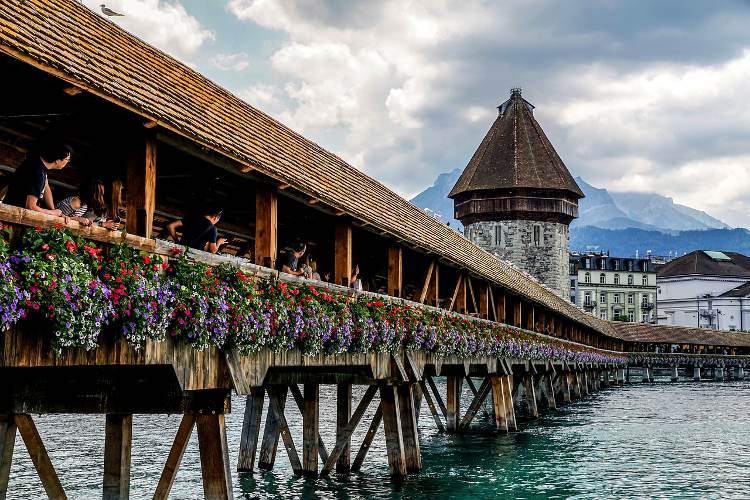Imagine you were standing on this bridge. Describe your experience. Standing on the Chapel Bridge in Lucerne, the first thing you notice is the subtle creaking of the wooden planks beneath your feet, a reminder of the structure's timeless presence. The smell of fresh flowers mingles with the crisp, cool air coming off the Reuss River below. Looking around, you're surrounded by a collage of vibrant blooms decorating the bridge's sides, their colors contrasting beautifully with the weathered wood. To your right, the formidable Water Tower stands as a sentinel of history. As you glance beyond, the Swiss Alps create a breathtaking backdrop, their snow-capped peaks piercing the sky. The atmosphere is a blend of tranquility and vibrant life, with tourists and locals alike meandering and snapping photos, all keen to capture a piece of this historical charm. If this bridge could talk, what stories do you think it would share? Oh, the tales the Chapel Bridge could tell! It would share stories from the days when it was part of Lucerne's fortifications, recounting the many feet that have tread upon its planks - merchants, soldiers, pilgrims and countless others. It would whisper of the fire in 1993 that almost erased it from existence, the heat of the flames and the efforts of the community to restore it to its former glory. The bridge might share glimpses of romantic strolls under moonlit skies, laughter and conversations remembered in the rustling of flowers, and the many faces that have paused to marvel at the panoramic views of the Reuss River and the majestic Alps. Each plank, each beam, would hold a fragment of Lucerne's rich tapestry of history and personal stories. 